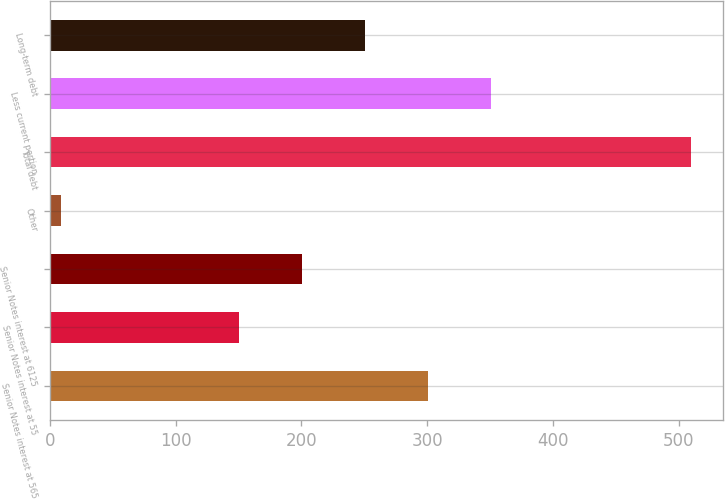Convert chart to OTSL. <chart><loc_0><loc_0><loc_500><loc_500><bar_chart><fcel>Senior Notes interest at 565<fcel>Senior Notes interest at 55<fcel>Senior Notes interest at 6125<fcel>Other<fcel>Total debt<fcel>Less current portion<fcel>Long-term debt<nl><fcel>300.3<fcel>150<fcel>200.1<fcel>9<fcel>510<fcel>351<fcel>250.2<nl></chart> 